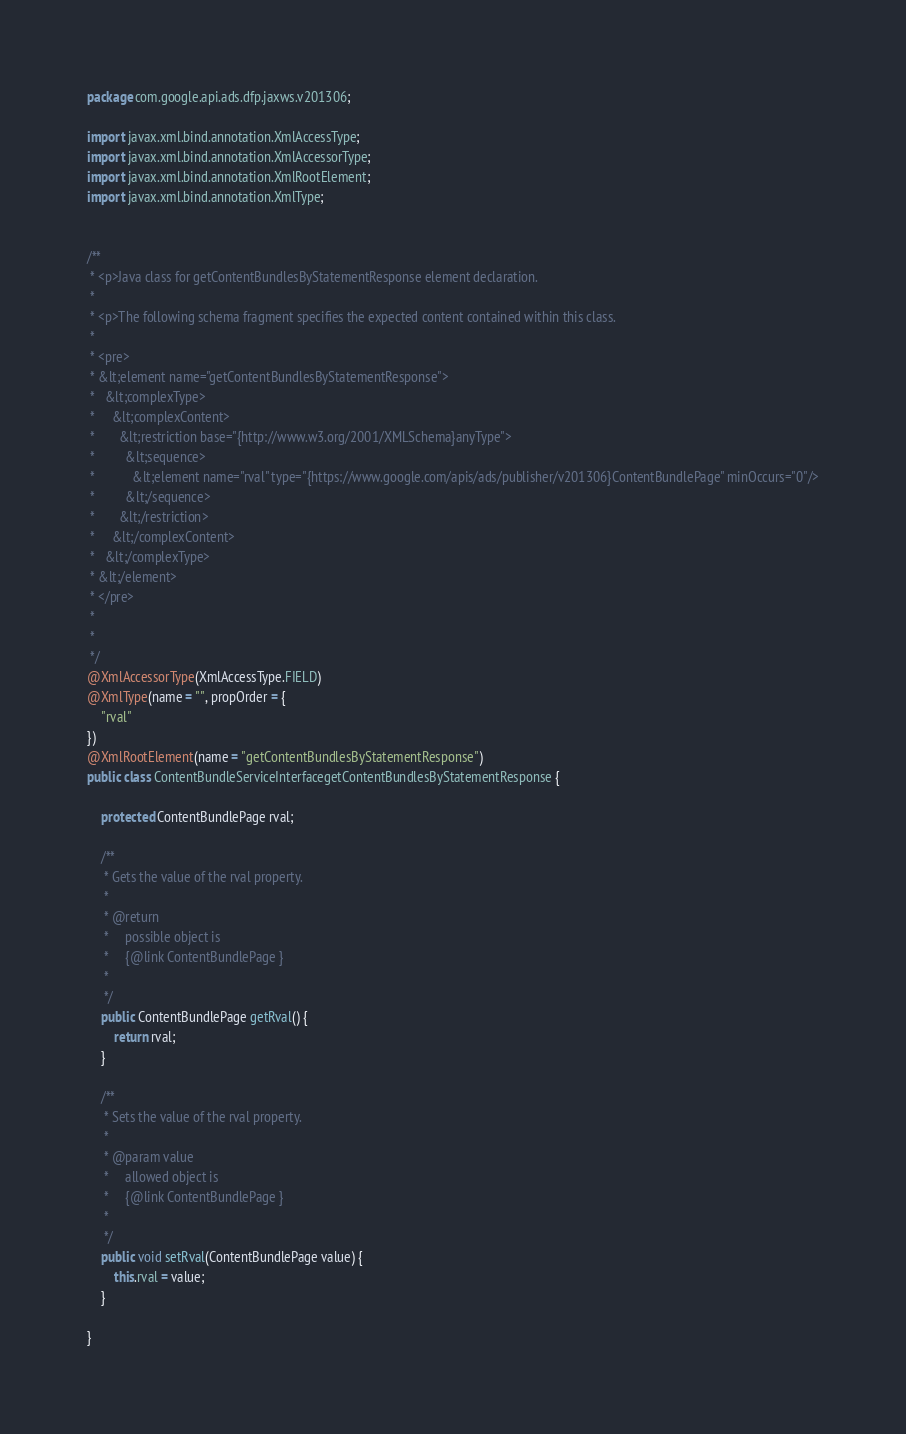<code> <loc_0><loc_0><loc_500><loc_500><_Java_>
package com.google.api.ads.dfp.jaxws.v201306;

import javax.xml.bind.annotation.XmlAccessType;
import javax.xml.bind.annotation.XmlAccessorType;
import javax.xml.bind.annotation.XmlRootElement;
import javax.xml.bind.annotation.XmlType;


/**
 * <p>Java class for getContentBundlesByStatementResponse element declaration.
 * 
 * <p>The following schema fragment specifies the expected content contained within this class.
 * 
 * <pre>
 * &lt;element name="getContentBundlesByStatementResponse">
 *   &lt;complexType>
 *     &lt;complexContent>
 *       &lt;restriction base="{http://www.w3.org/2001/XMLSchema}anyType">
 *         &lt;sequence>
 *           &lt;element name="rval" type="{https://www.google.com/apis/ads/publisher/v201306}ContentBundlePage" minOccurs="0"/>
 *         &lt;/sequence>
 *       &lt;/restriction>
 *     &lt;/complexContent>
 *   &lt;/complexType>
 * &lt;/element>
 * </pre>
 * 
 * 
 */
@XmlAccessorType(XmlAccessType.FIELD)
@XmlType(name = "", propOrder = {
    "rval"
})
@XmlRootElement(name = "getContentBundlesByStatementResponse")
public class ContentBundleServiceInterfacegetContentBundlesByStatementResponse {

    protected ContentBundlePage rval;

    /**
     * Gets the value of the rval property.
     * 
     * @return
     *     possible object is
     *     {@link ContentBundlePage }
     *     
     */
    public ContentBundlePage getRval() {
        return rval;
    }

    /**
     * Sets the value of the rval property.
     * 
     * @param value
     *     allowed object is
     *     {@link ContentBundlePage }
     *     
     */
    public void setRval(ContentBundlePage value) {
        this.rval = value;
    }

}
</code> 